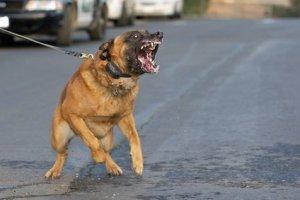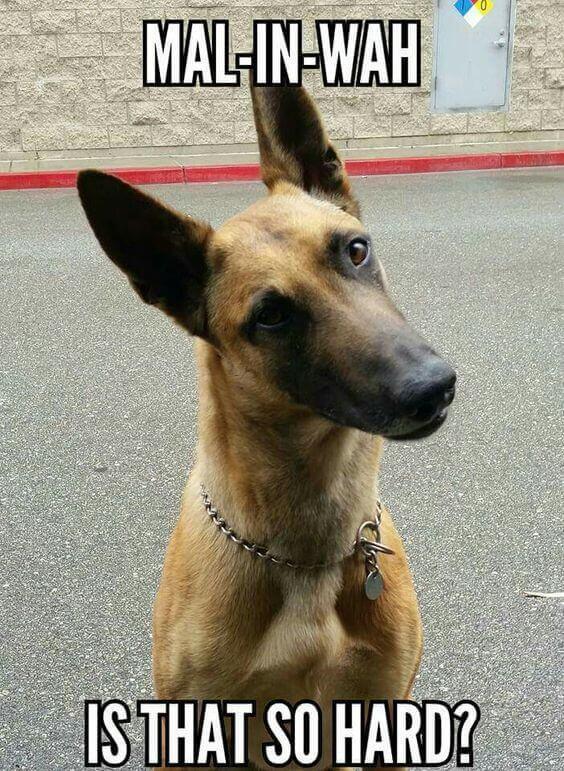The first image is the image on the left, the second image is the image on the right. Analyze the images presented: Is the assertion "One dog is lying down." valid? Answer yes or no. No. The first image is the image on the left, the second image is the image on the right. For the images displayed, is the sentence "The right image contains one german shepherd on pavement, looking upward with his head cocked rightward." factually correct? Answer yes or no. Yes. 